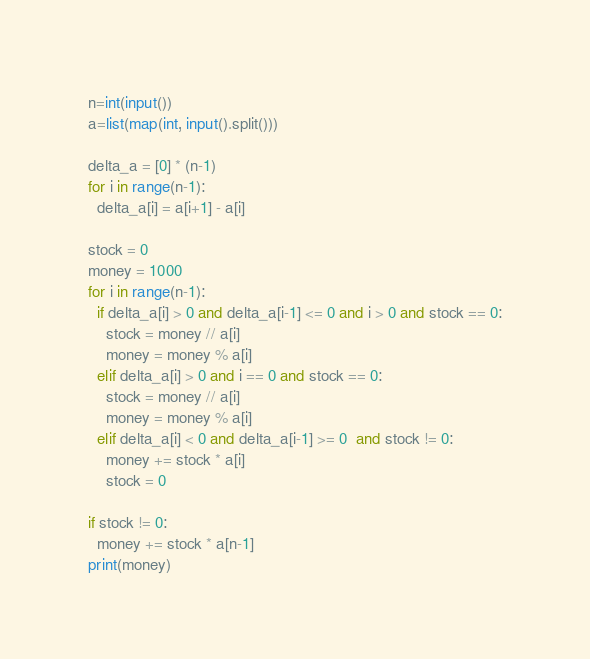<code> <loc_0><loc_0><loc_500><loc_500><_Python_>n=int(input())
a=list(map(int, input().split()))

delta_a = [0] * (n-1)
for i in range(n-1):
  delta_a[i] = a[i+1] - a[i]

stock = 0
money = 1000
for i in range(n-1):
  if delta_a[i] > 0 and delta_a[i-1] <= 0 and i > 0 and stock == 0:
    stock = money // a[i]
    money = money % a[i]
  elif delta_a[i] > 0 and i == 0 and stock == 0:
    stock = money // a[i]
    money = money % a[i]
  elif delta_a[i] < 0 and delta_a[i-1] >= 0  and stock != 0:
    money += stock * a[i]
    stock = 0

if stock != 0:
  money += stock * a[n-1]
print(money)</code> 